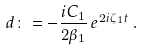Convert formula to latex. <formula><loc_0><loc_0><loc_500><loc_500>d \colon = - \frac { i C _ { 1 } } { 2 \beta _ { 1 } } \, e ^ { 2 i \zeta _ { 1 } t } \, .</formula> 